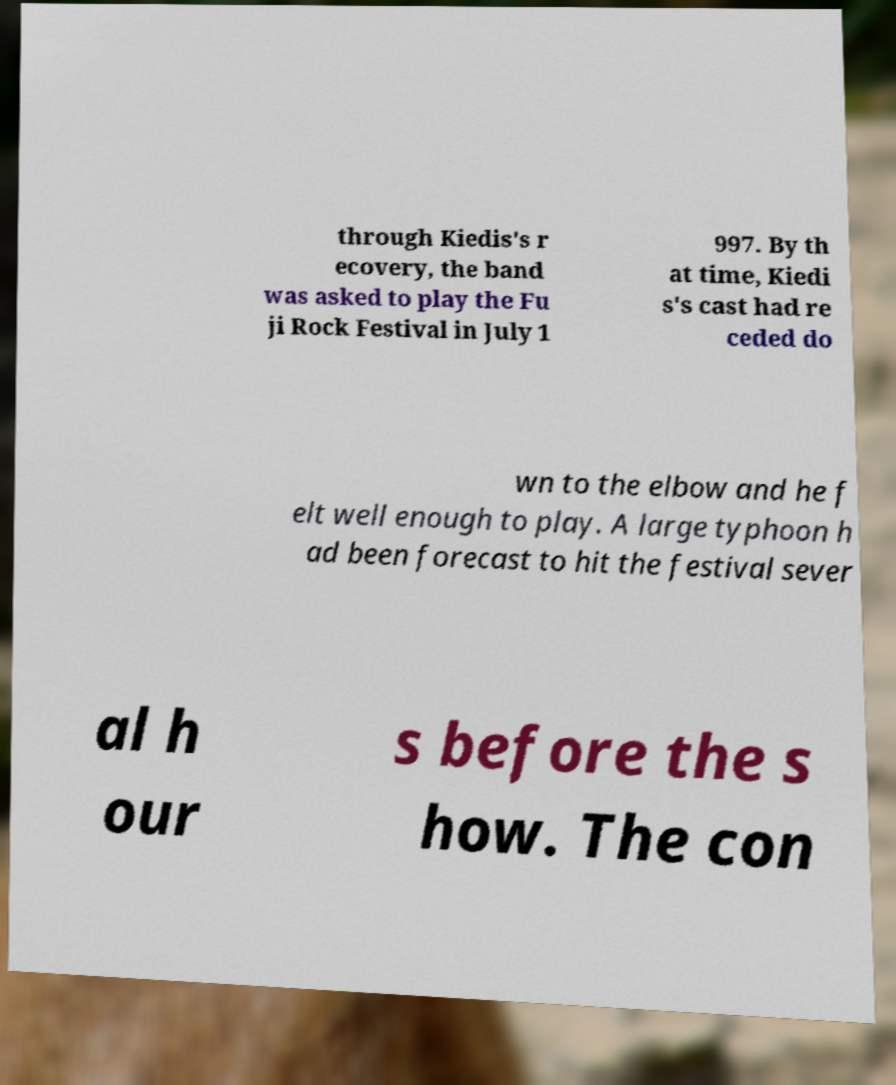What messages or text are displayed in this image? I need them in a readable, typed format. through Kiedis's r ecovery, the band was asked to play the Fu ji Rock Festival in July 1 997. By th at time, Kiedi s's cast had re ceded do wn to the elbow and he f elt well enough to play. A large typhoon h ad been forecast to hit the festival sever al h our s before the s how. The con 